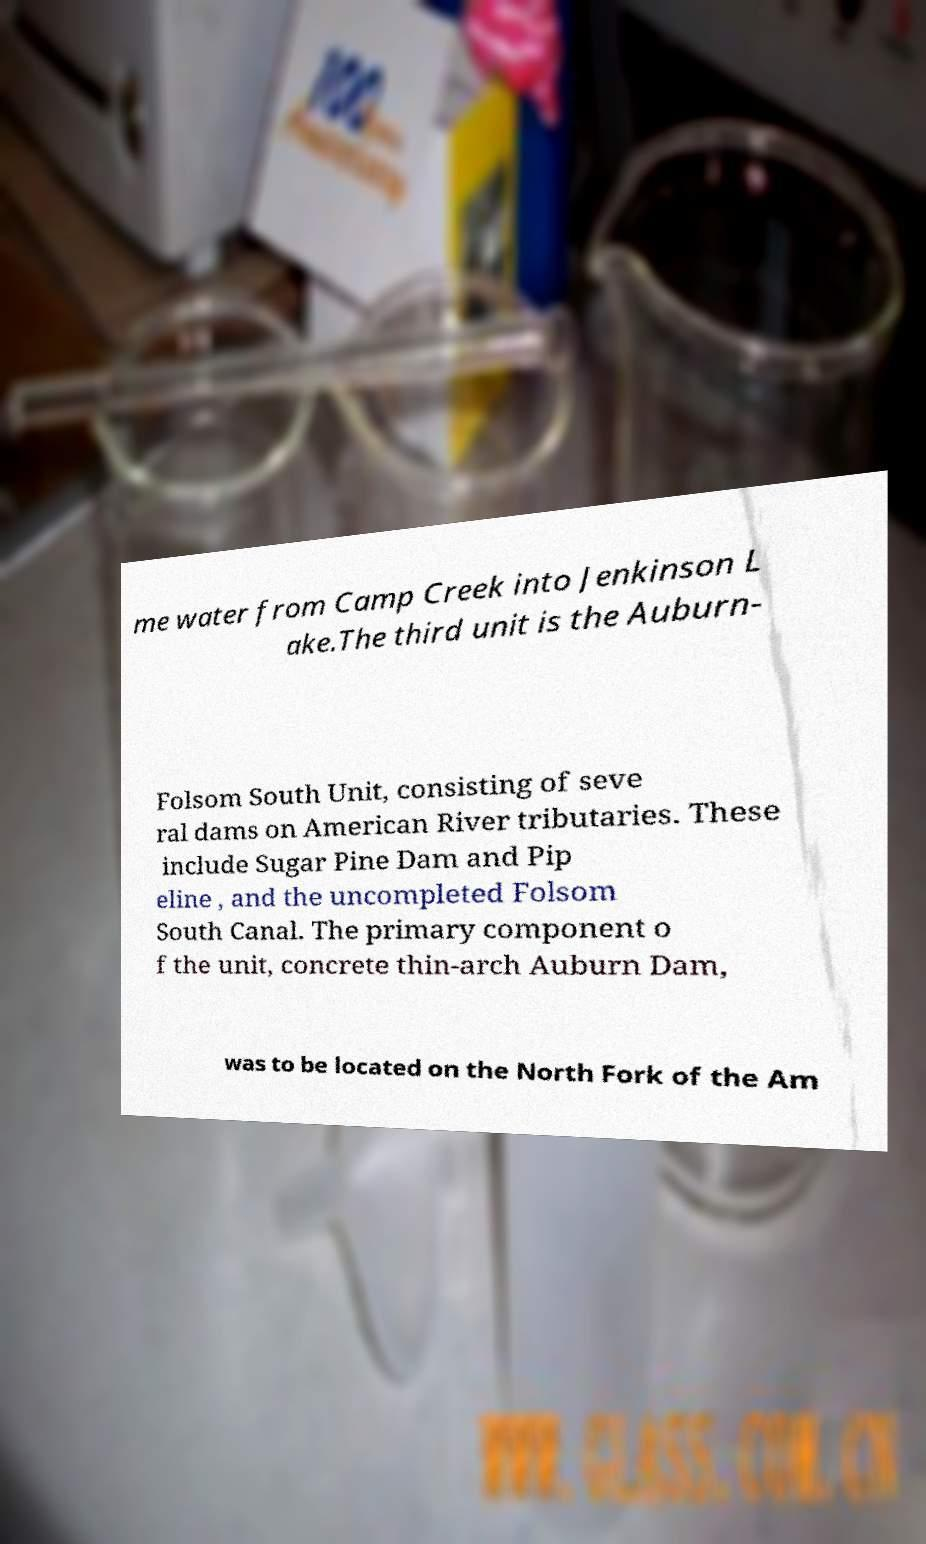Please read and relay the text visible in this image. What does it say? me water from Camp Creek into Jenkinson L ake.The third unit is the Auburn- Folsom South Unit, consisting of seve ral dams on American River tributaries. These include Sugar Pine Dam and Pip eline , and the uncompleted Folsom South Canal. The primary component o f the unit, concrete thin-arch Auburn Dam, was to be located on the North Fork of the Am 